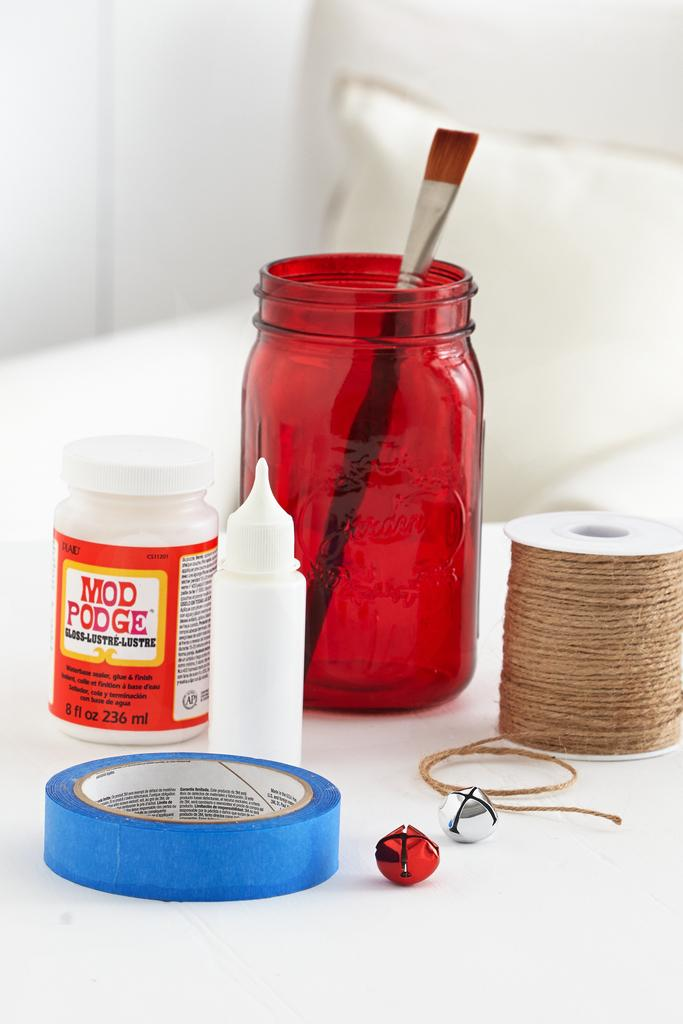<image>
Describe the image concisely. A red jar has a paint brush in it, a bottle of Mod Podge, and twine. 